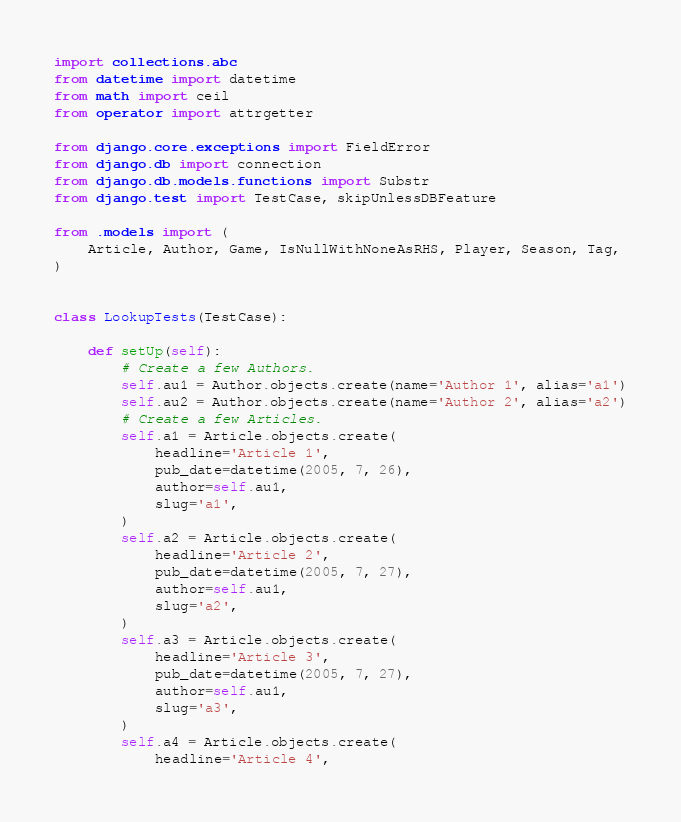<code> <loc_0><loc_0><loc_500><loc_500><_Python_>import collections.abc
from datetime import datetime
from math import ceil
from operator import attrgetter

from django.core.exceptions import FieldError
from django.db import connection
from django.db.models.functions import Substr
from django.test import TestCase, skipUnlessDBFeature

from .models import (
    Article, Author, Game, IsNullWithNoneAsRHS, Player, Season, Tag,
)


class LookupTests(TestCase):

    def setUp(self):
        # Create a few Authors.
        self.au1 = Author.objects.create(name='Author 1', alias='a1')
        self.au2 = Author.objects.create(name='Author 2', alias='a2')
        # Create a few Articles.
        self.a1 = Article.objects.create(
            headline='Article 1',
            pub_date=datetime(2005, 7, 26),
            author=self.au1,
            slug='a1',
        )
        self.a2 = Article.objects.create(
            headline='Article 2',
            pub_date=datetime(2005, 7, 27),
            author=self.au1,
            slug='a2',
        )
        self.a3 = Article.objects.create(
            headline='Article 3',
            pub_date=datetime(2005, 7, 27),
            author=self.au1,
            slug='a3',
        )
        self.a4 = Article.objects.create(
            headline='Article 4',</code> 